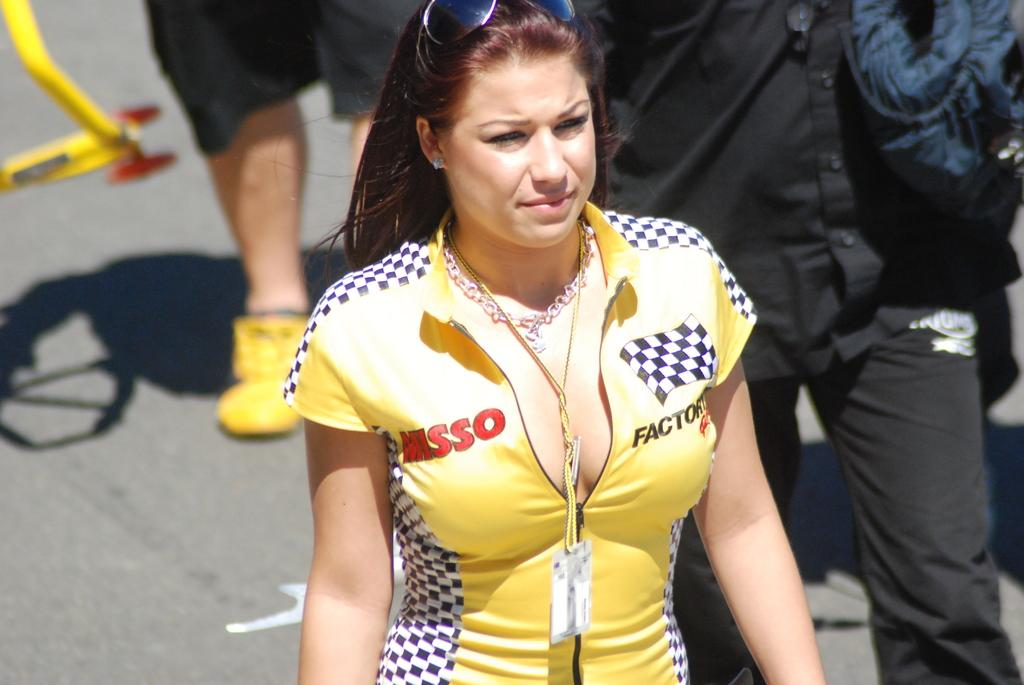<image>
Write a terse but informative summary of the picture. The woman with the tight shirt on is sponsored by Misso. 